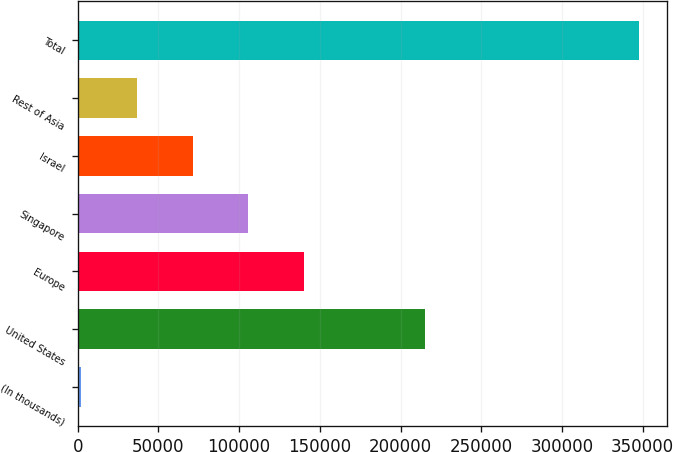Convert chart to OTSL. <chart><loc_0><loc_0><loc_500><loc_500><bar_chart><fcel>(In thousands)<fcel>United States<fcel>Europe<fcel>Singapore<fcel>Israel<fcel>Rest of Asia<fcel>Total<nl><fcel>2013<fcel>215136<fcel>140311<fcel>105737<fcel>71162.2<fcel>36587.6<fcel>347759<nl></chart> 